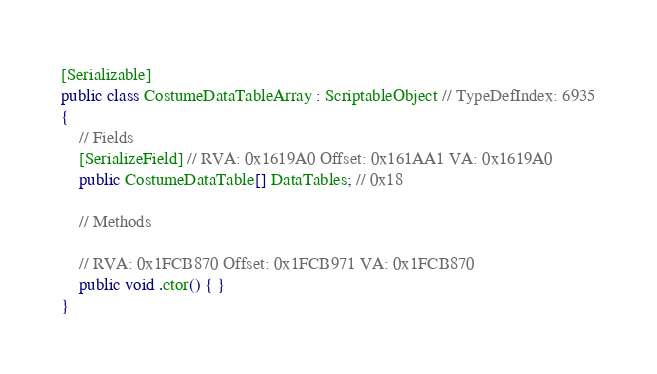Convert code to text. <code><loc_0><loc_0><loc_500><loc_500><_C#_>[Serializable]
public class CostumeDataTableArray : ScriptableObject // TypeDefIndex: 6935
{
	// Fields
	[SerializeField] // RVA: 0x1619A0 Offset: 0x161AA1 VA: 0x1619A0
	public CostumeDataTable[] DataTables; // 0x18

	// Methods

	// RVA: 0x1FCB870 Offset: 0x1FCB971 VA: 0x1FCB870
	public void .ctor() { }
}

</code> 